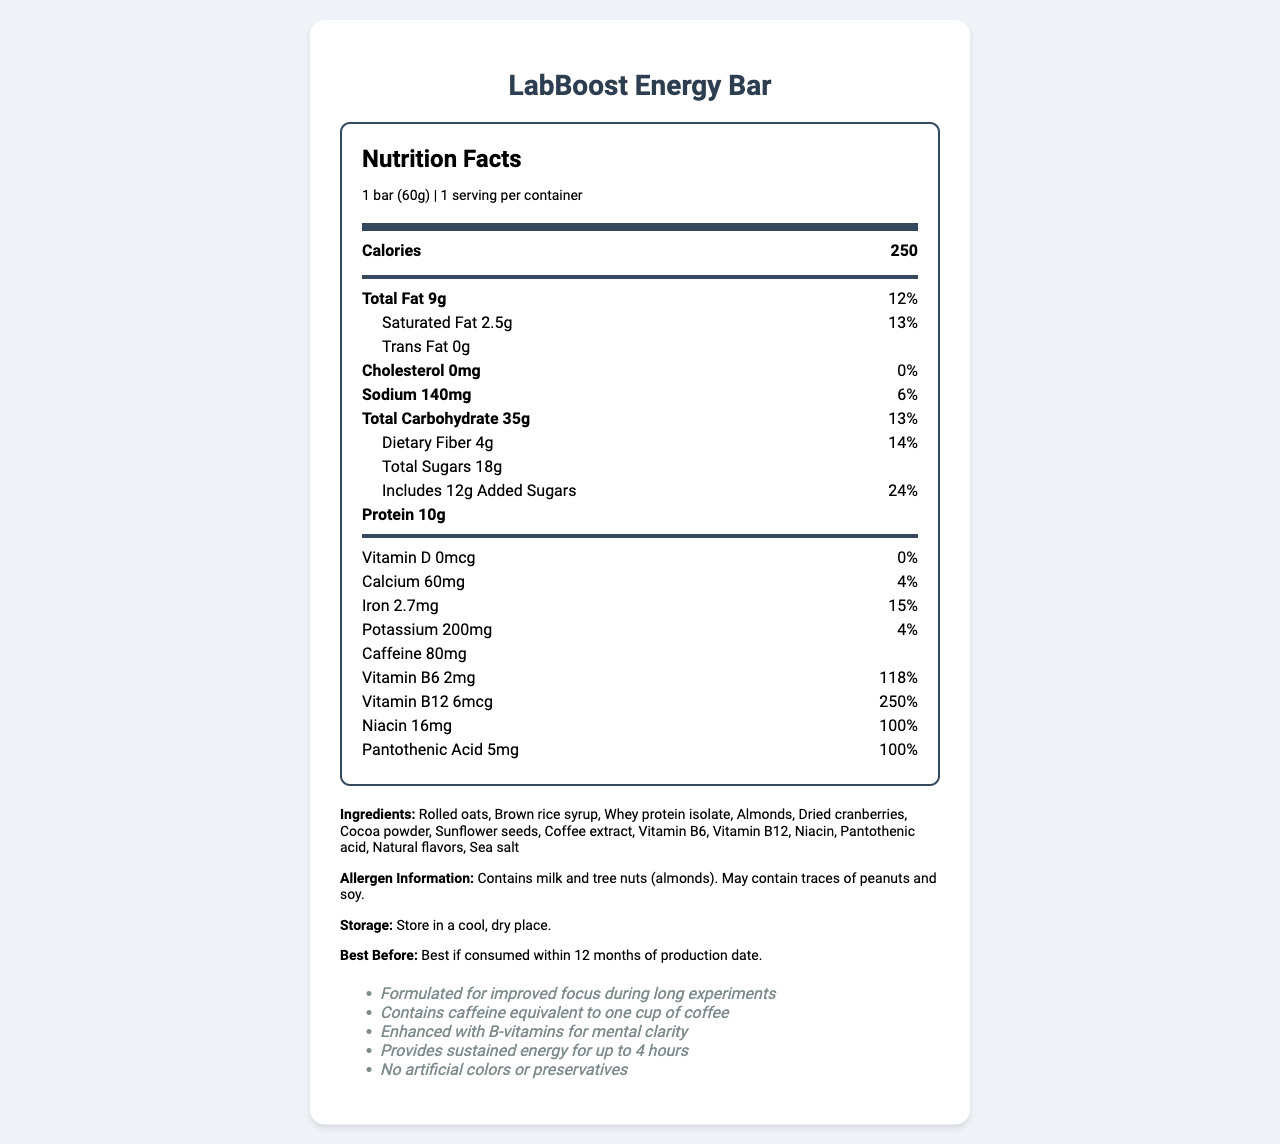what is the serving size of the LabBoost Energy Bar? The serving size is printed clearly on the nutrition label: "1 bar (60g)".
Answer: 1 bar (60g) how many calories are in one serving of the LabBoost Energy Bar? The number of calories per serving is stated in bold in the section "main-info": "Calories 250".
Answer: 250 what is the total amount of sugars in the LabBoost Energy Bar? The "Total Sugars" value is listed as 18g under the total carbohydrate section.
Answer: 18g how much vitamin B12 does one serving of the LabBoost Energy Bar contain? This information is provided in the vitamins section: "Vitamin B12 6mcg".
Answer: 6mcg what is the daily value percentage of Saturated Fat in the LabBoost Energy Bar? The percentage is shown next to the amount of Saturated Fat: "Saturated Fat 2.5g 13%".
Answer: 13% Which ingredient is not found in the LabBoost Energy Bar? A. Almonds B. Dried cranberries C. Peanuts D. Whey protein isolate Peanuts are not listed in the ingredients section: "Rolled oats, Brown rice syrup, Whey protein isolate, Almonds, Dried cranberries, Cocoa powder, Sunflower seeds, Coffee extract, Vitamin B6, Vitamin B12, Niacin, Pantothenic acid, Natural flavors, Sea salt".
Answer: C What is the daily value percentage of Iron in the LabBoost Energy Bar? A. 4% B. 14% C. 15% D. 118% The daily value percentage of Iron is "15%" as indicated in the vitamins section: "Iron 2.7mg 15%".
Answer: C Does the LabBoost Energy Bar contain any trans fat? The nutrition label clearly states that the "Trans Fat" content is "0g".
Answer: No Summarize the main idea of the document The document is a detailed nutrition facts label for the LabBoost Energy Bar. It emphasizes the bar's calorie content, presence of B-vitamins, caffeine, as well as other nutritional information like fats, cholesterol, sodium, carbohydrates, protein, and specific vitamins and minerals. It also lists the product's ingredients, allergen information, and product claims.
Answer: The document provides comprehensive nutritional information about the LabBoost Energy Bar, highlighting its ingredients, nutritional content per serving, and claims such as improved focus, mental clarity, and sustained energy. It also includes allergen information, storage instructions, and expiration details. how much caffeine is in one serving of the LabBoost Energy Bar? The caffeine content per serving is listed in the vitamins section: "Caffeine 80mg".
Answer: 80mg Is the LabBoost Energy Bar suitable for people with nut allergies? The allergen information states: "Contains milk and tree nuts (almonds). May contain traces of peanuts and soy."
Answer: No how many grams of dietary fiber are in each LabBoost Energy Bar? The dietary fiber content is included under the total carbohydrate section: "Dietary Fiber 4g".
Answer: 4g how long can the LabBoost Energy Bar be stored before it expires? According to the storage information, the bar is best if consumed within 12 months of the production date.
Answer: 12 months what is the main source of protein in the LabBoost Energy Bar? Whey protein isolate is listed as one of the primary ingredients.
Answer: Whey protein isolate what is the manufacturer of the LabBoost Energy Bar? The manufacturer's information can be found towards the bottom of the document: "NutriLab Sciences, Inc.".
Answer: NutriLab Sciences, Inc. where is the barcode located on the LabBoost Energy Bar? The visual information in the document does not provide the exact location of the barcode, only the barcode number is mentioned: "890123456789".
Answer: Cannot be determined 